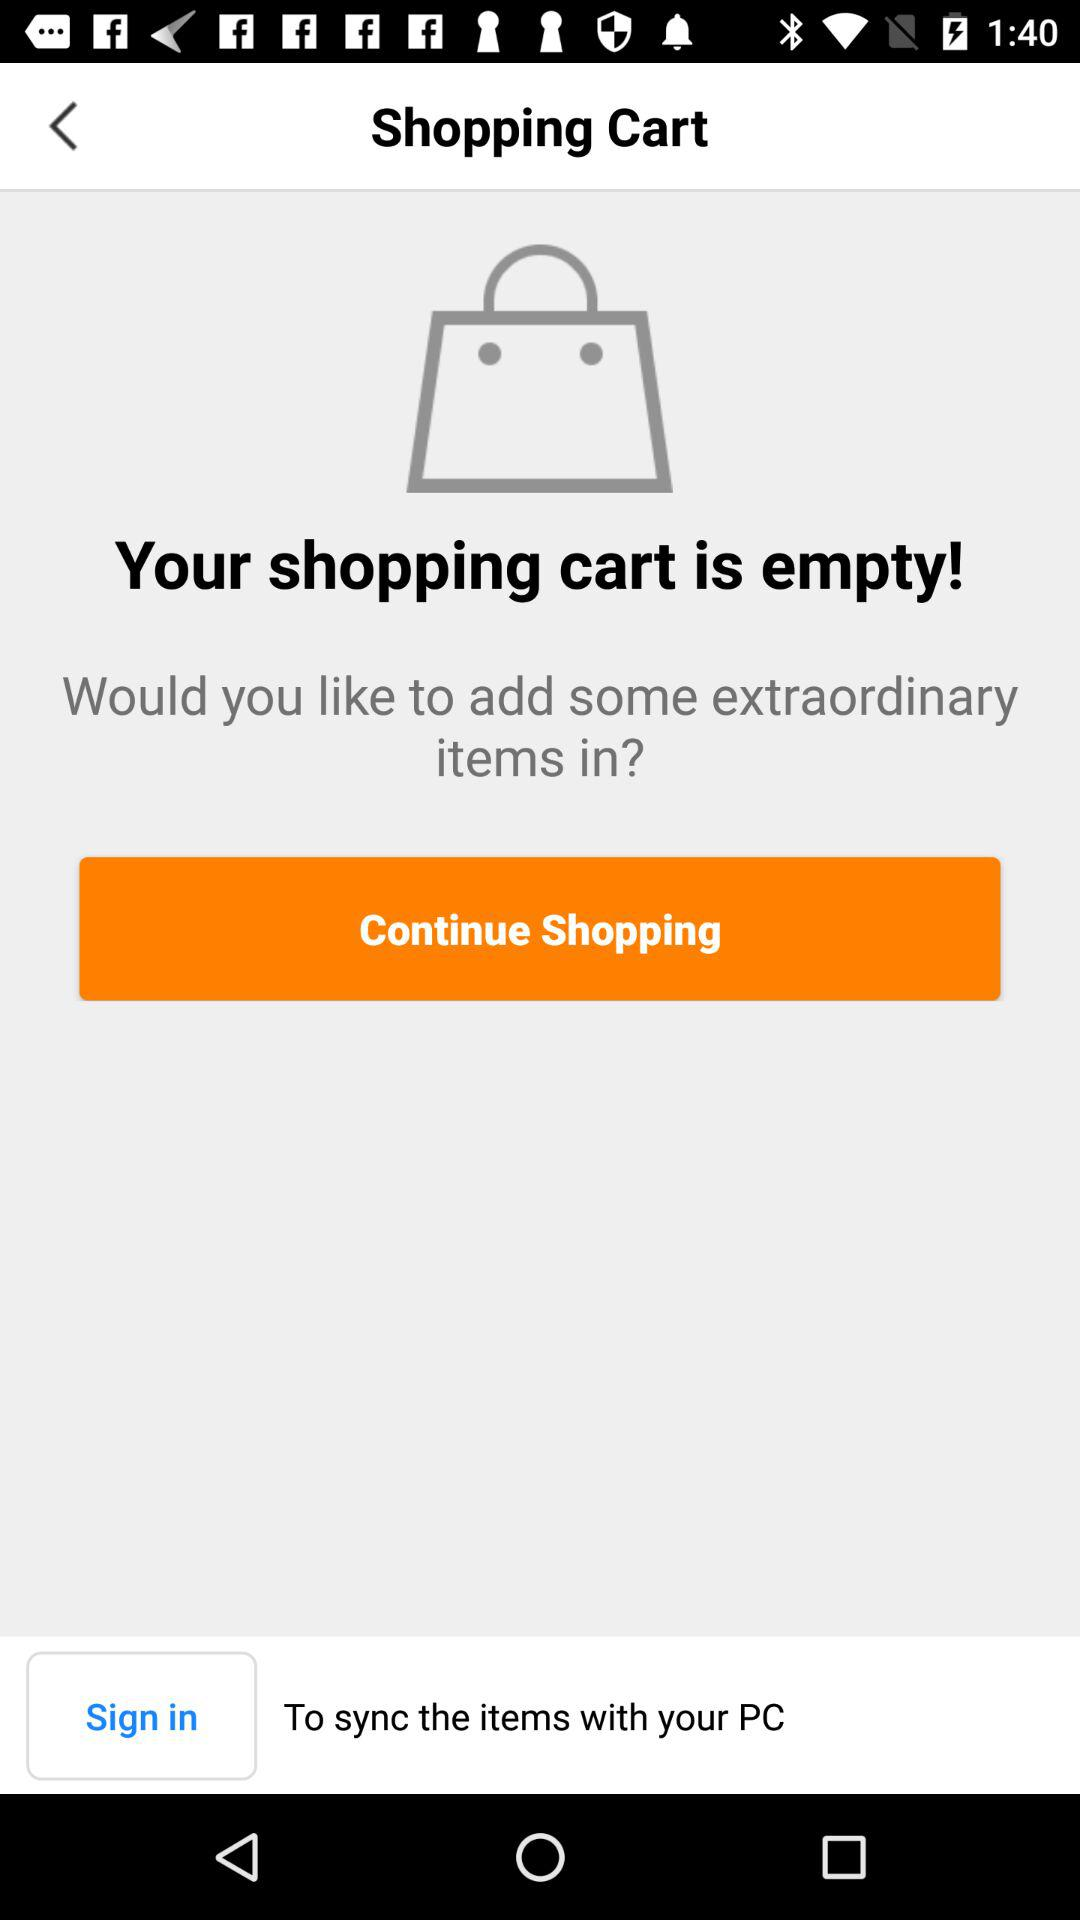How many empty shopping carts are there?
Answer the question using a single word or phrase. 1 